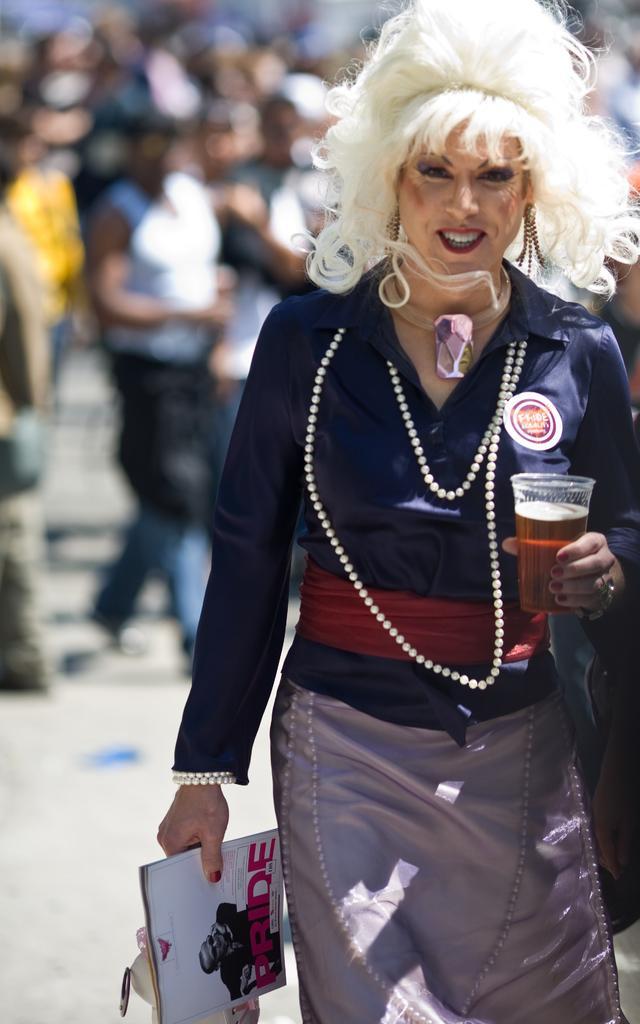Could you give a brief overview of what you see in this image? In this image in the foreground there is one woman who is holding glass, and some books and she is wearing some costumes. In the background there are a group of people, at the bottom there is a walkway. 